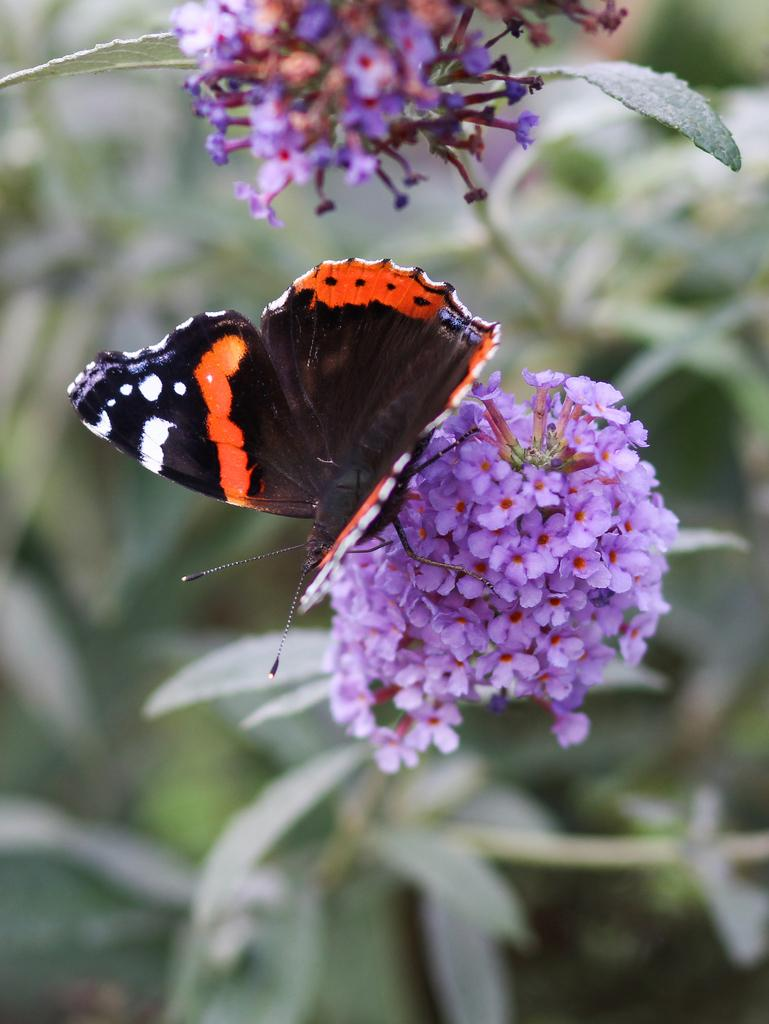What is the main subject in the image? There is a butterfly in the image. Where is the butterfly located? The butterfly is on a flower. What is the flower a part of? The flower is part of a plant. What type of alley can be seen behind the houses in the image? There are no houses or alleys present in the image; it features a butterfly on a flower. How many marks are visible on the butterfly's wings in the image? The image does not provide enough detail to determine the number of marks on the butterfly's wings. 